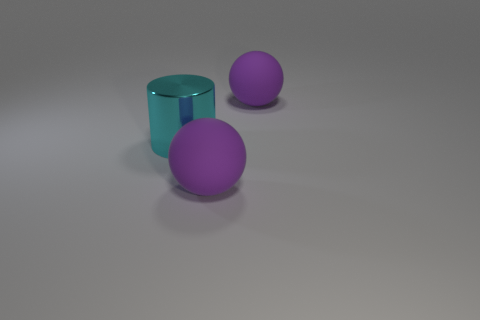Subtract 2 spheres. How many spheres are left? 0 Add 3 blue metallic blocks. How many objects exist? 6 Subtract all cylinders. How many objects are left? 2 Add 3 metal cylinders. How many metal cylinders are left? 4 Add 1 large shiny objects. How many large shiny objects exist? 2 Subtract 0 purple cylinders. How many objects are left? 3 Subtract all yellow spheres. Subtract all cyan cubes. How many spheres are left? 2 Subtract all large purple spheres. Subtract all metal cylinders. How many objects are left? 0 